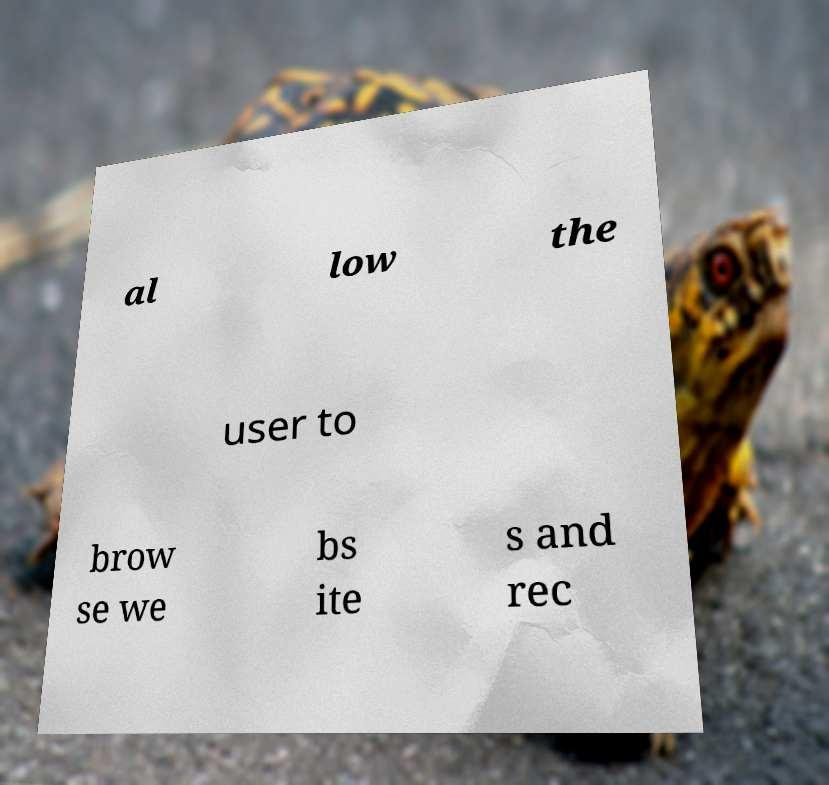Can you accurately transcribe the text from the provided image for me? al low the user to brow se we bs ite s and rec 